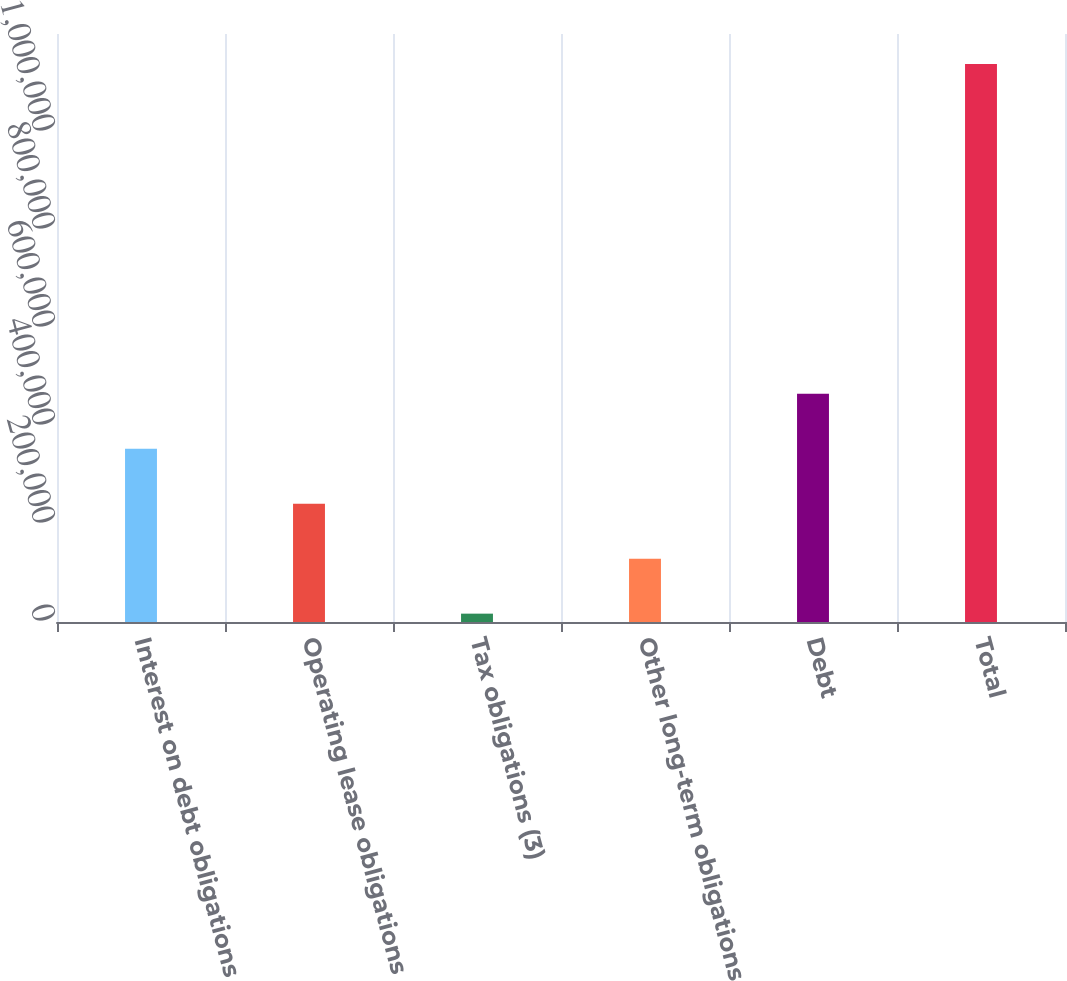<chart> <loc_0><loc_0><loc_500><loc_500><bar_chart><fcel>Interest on debt obligations<fcel>Operating lease obligations<fcel>Tax obligations (3)<fcel>Other long-term obligations<fcel>Debt<fcel>Total<nl><fcel>353538<fcel>241371<fcel>17038<fcel>129204<fcel>465704<fcel>1.1387e+06<nl></chart> 